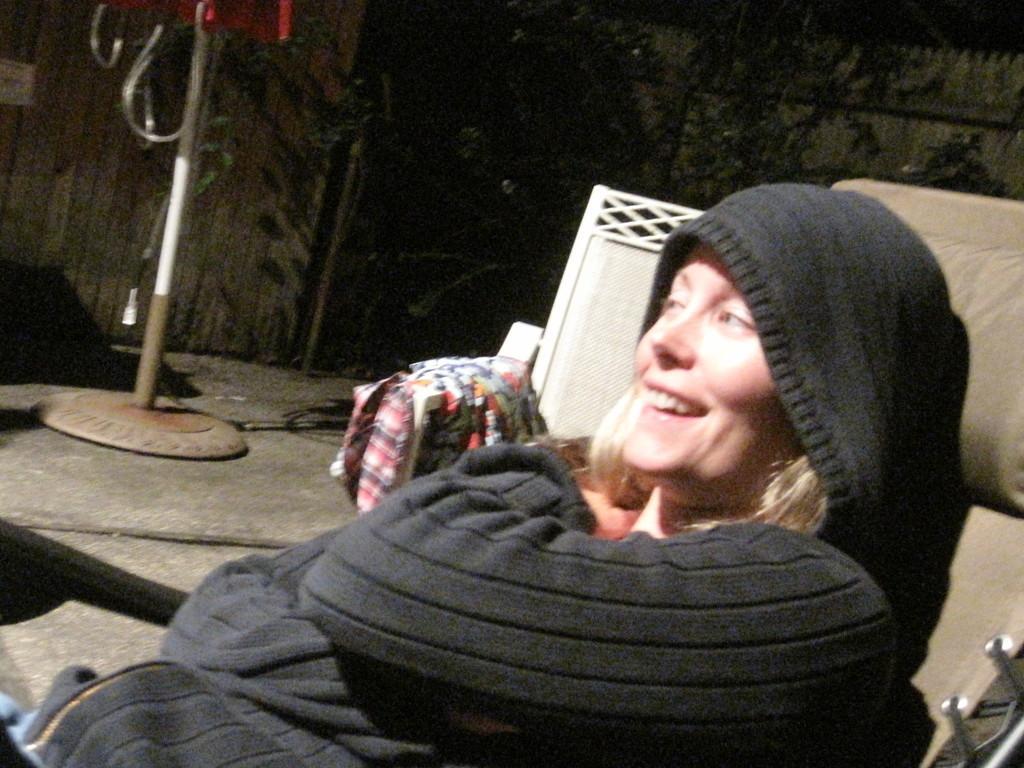How would you summarize this image in a sentence or two? This picture shows a woman seated on the chair and we see another chair on the side with some clothes on it and we see a stand and a tree and we see women wore a cap on her head and we see smile on her face. 